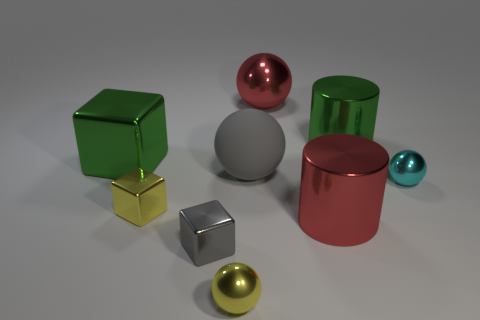Are there any big shiny objects of the same color as the big block?
Give a very brief answer. Yes. Is the size of the ball in front of the small yellow cube the same as the yellow metal thing behind the gray metal cube?
Your response must be concise. Yes. The thing that is on the left side of the gray rubber thing and on the right side of the gray block is made of what material?
Provide a succinct answer. Metal. What is the size of the shiny block that is the same color as the rubber thing?
Provide a succinct answer. Small. How many other objects are the same size as the green cylinder?
Keep it short and to the point. 4. What material is the small sphere that is left of the small cyan ball?
Give a very brief answer. Metal. Do the small cyan shiny thing and the matte object have the same shape?
Offer a terse response. Yes. How many other things are the same shape as the gray shiny thing?
Provide a succinct answer. 2. What is the color of the small sphere behind the gray block?
Give a very brief answer. Cyan. Do the red cylinder and the red sphere have the same size?
Your response must be concise. Yes. 